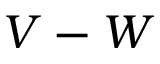<formula> <loc_0><loc_0><loc_500><loc_500>V - W</formula> 